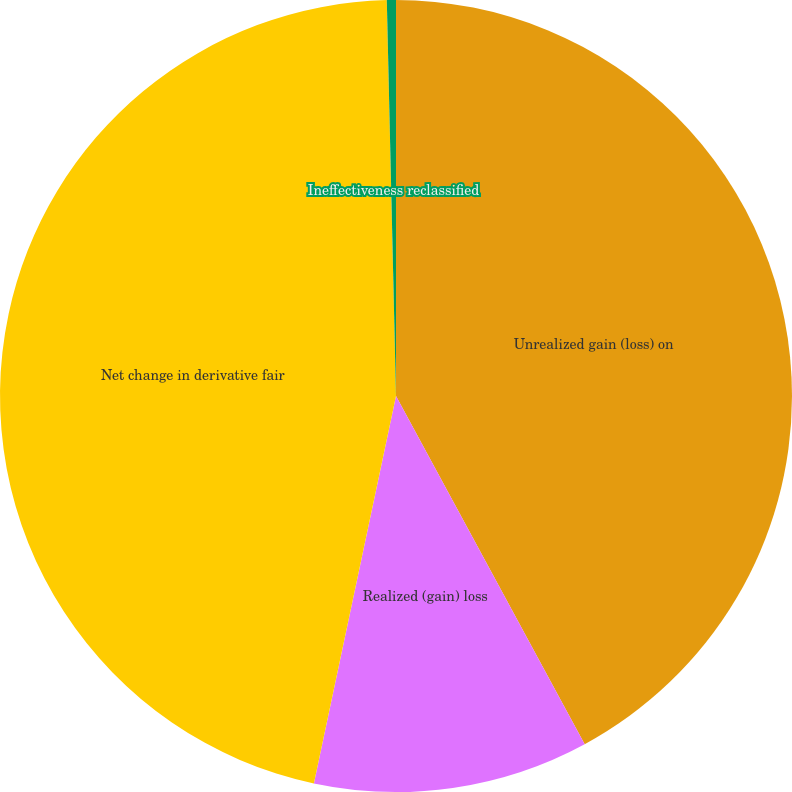<chart> <loc_0><loc_0><loc_500><loc_500><pie_chart><fcel>Unrealized gain (loss) on<fcel>Realized (gain) loss<fcel>Net change in derivative fair<fcel>Ineffectiveness reclassified<nl><fcel>42.1%<fcel>11.23%<fcel>46.31%<fcel>0.37%<nl></chart> 